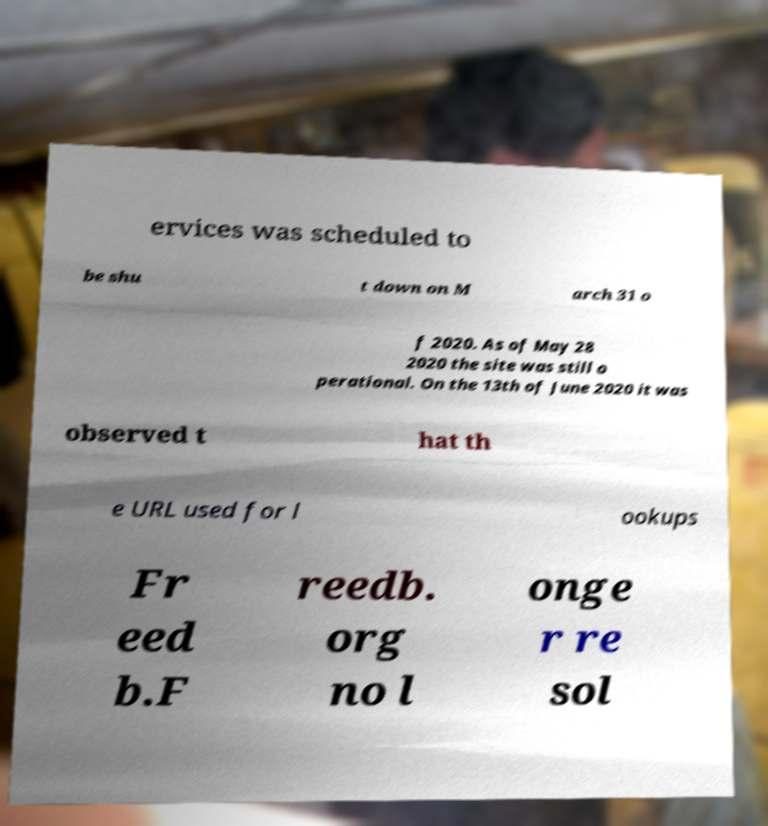Could you assist in decoding the text presented in this image and type it out clearly? ervices was scheduled to be shu t down on M arch 31 o f 2020. As of May 28 2020 the site was still o perational. On the 13th of June 2020 it was observed t hat th e URL used for l ookups Fr eed b.F reedb. org no l onge r re sol 